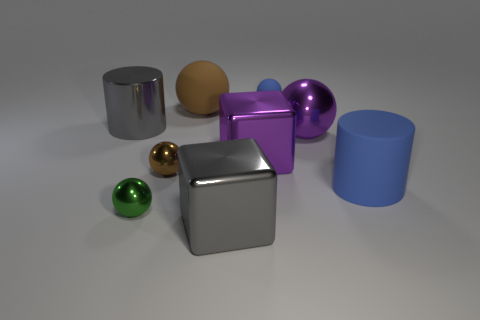The big sphere to the left of the purple metal object that is to the left of the small blue object is made of what material?
Give a very brief answer. Rubber. Is the material of the blue thing right of the small matte object the same as the small blue thing?
Make the answer very short. Yes. What size is the brown shiny ball on the left side of the large blue cylinder?
Your answer should be compact. Small. There is a large rubber object to the left of the big gray cube; is there a large matte thing that is to the right of it?
Offer a terse response. Yes. Does the big shiny cube behind the big blue cylinder have the same color as the big ball that is right of the tiny blue object?
Give a very brief answer. Yes. What color is the big metal cylinder?
Provide a short and direct response. Gray. There is a big object that is both in front of the purple shiny ball and behind the tiny brown object; what is its color?
Offer a very short reply. Purple. Do the gray object that is behind the blue rubber cylinder and the purple cube have the same size?
Provide a succinct answer. Yes. Are there more blue matte cylinders that are to the right of the green shiny ball than small purple objects?
Keep it short and to the point. Yes. Is the shape of the tiny green metallic object the same as the big blue matte thing?
Your answer should be compact. No. 